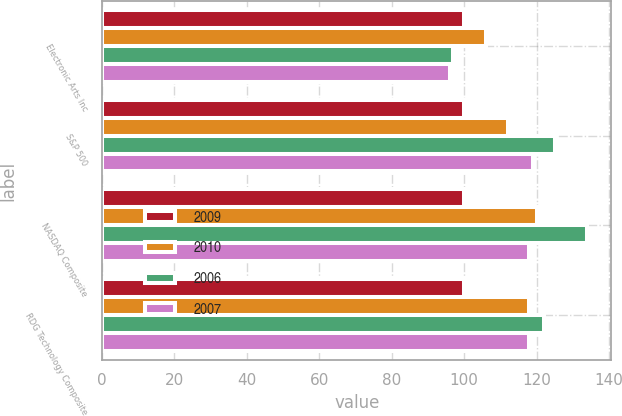Convert chart to OTSL. <chart><loc_0><loc_0><loc_500><loc_500><stacked_bar_chart><ecel><fcel>Electronic Arts Inc<fcel>S&P 500<fcel>NASDAQ Composite<fcel>RDG Technology Composite<nl><fcel>2009<fcel>100<fcel>100<fcel>100<fcel>100<nl><fcel>2010<fcel>106<fcel>112<fcel>120<fcel>118<nl><fcel>2006<fcel>97<fcel>125<fcel>134<fcel>122<nl><fcel>2007<fcel>96<fcel>119<fcel>118<fcel>118<nl></chart> 